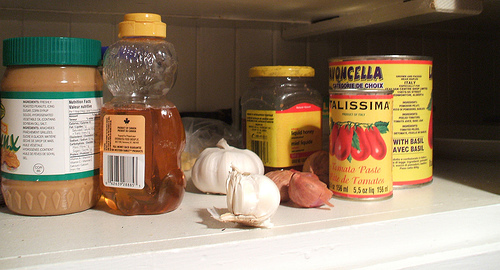<image>
Is the peanut butter next to the tomatoes? No. The peanut butter is not positioned next to the tomatoes. They are located in different areas of the scene. 